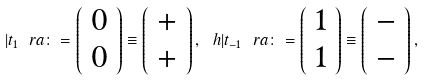Convert formula to latex. <formula><loc_0><loc_0><loc_500><loc_500>| t _ { 1 } \ r a \colon = \left ( \begin{array} { c } 0 \\ 0 \end{array} \right ) \equiv \left ( \begin{array} { c } + \\ + \end{array} \right ) , \ h | t _ { - 1 } \ r a \colon = \left ( \begin{array} { c } 1 \\ 1 \end{array} \right ) \equiv \left ( \begin{array} { c } - \\ - \end{array} \right ) ,</formula> 